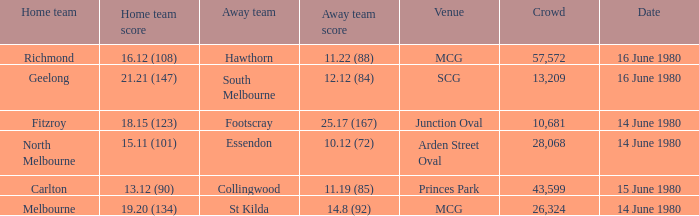On what date the footscray's away game? 14 June 1980. 